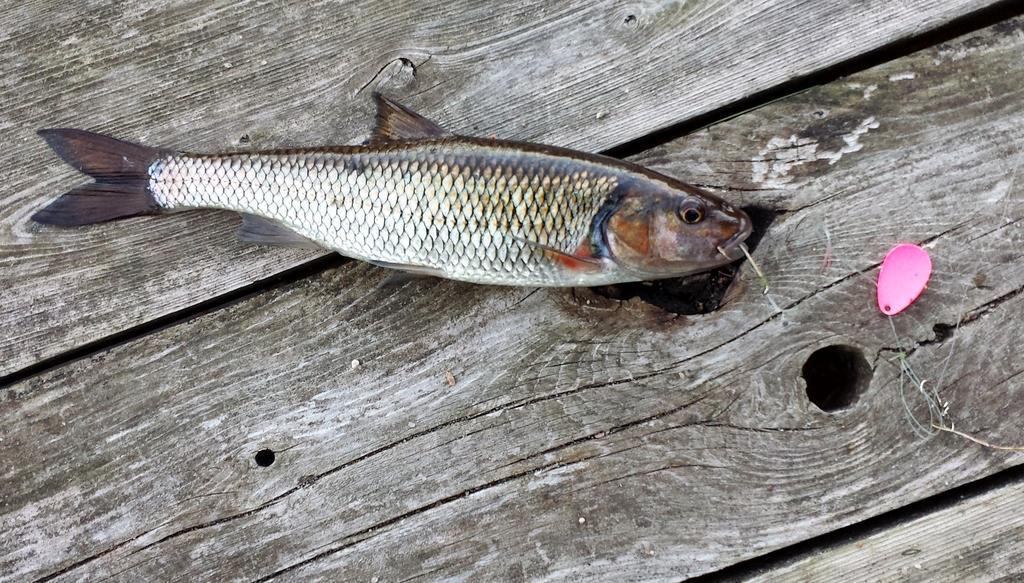In one or two sentences, can you explain what this image depicts? In this image we can see a fish on the surface which looks like a table and also there is an object. 